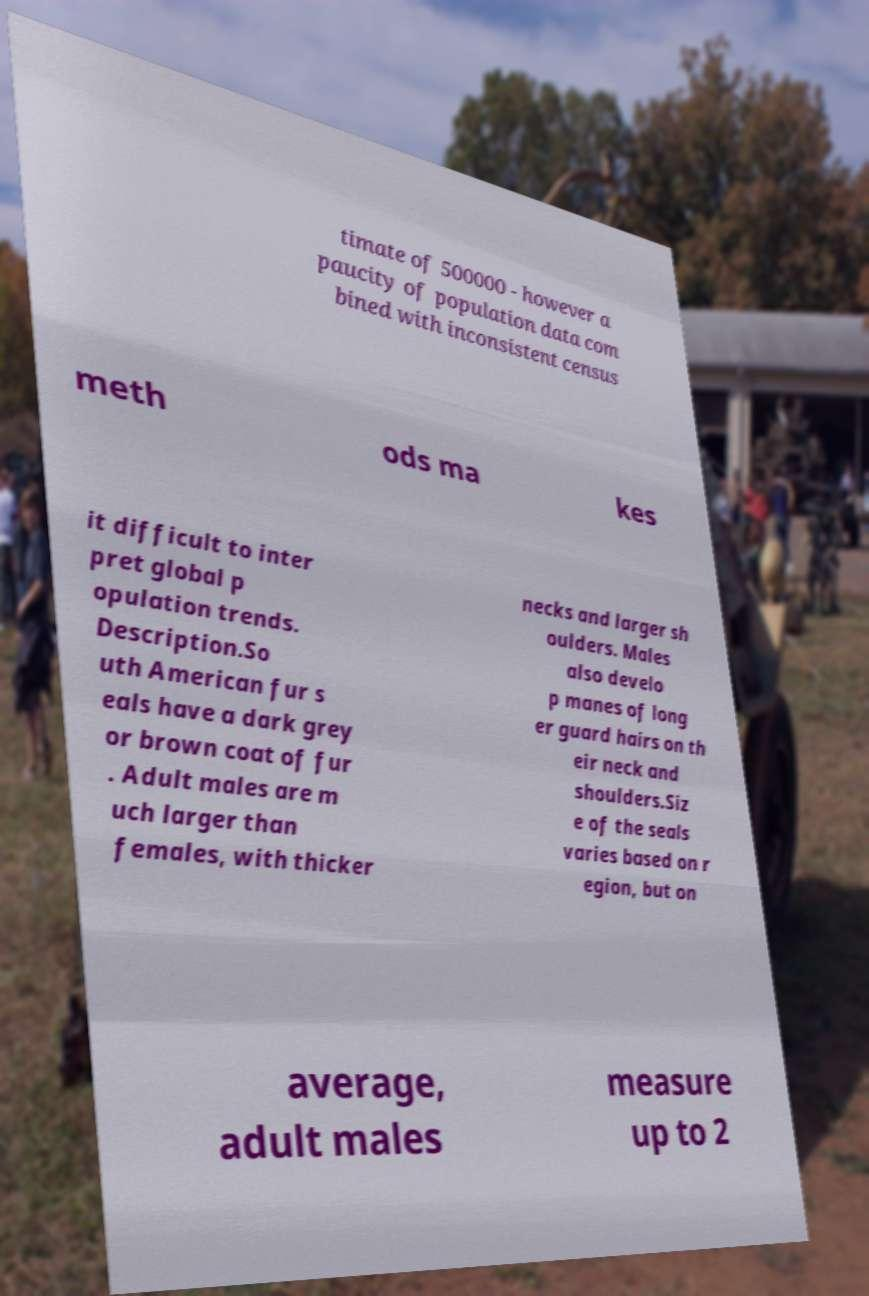Could you extract and type out the text from this image? timate of 500000 - however a paucity of population data com bined with inconsistent census meth ods ma kes it difficult to inter pret global p opulation trends. Description.So uth American fur s eals have a dark grey or brown coat of fur . Adult males are m uch larger than females, with thicker necks and larger sh oulders. Males also develo p manes of long er guard hairs on th eir neck and shoulders.Siz e of the seals varies based on r egion, but on average, adult males measure up to 2 